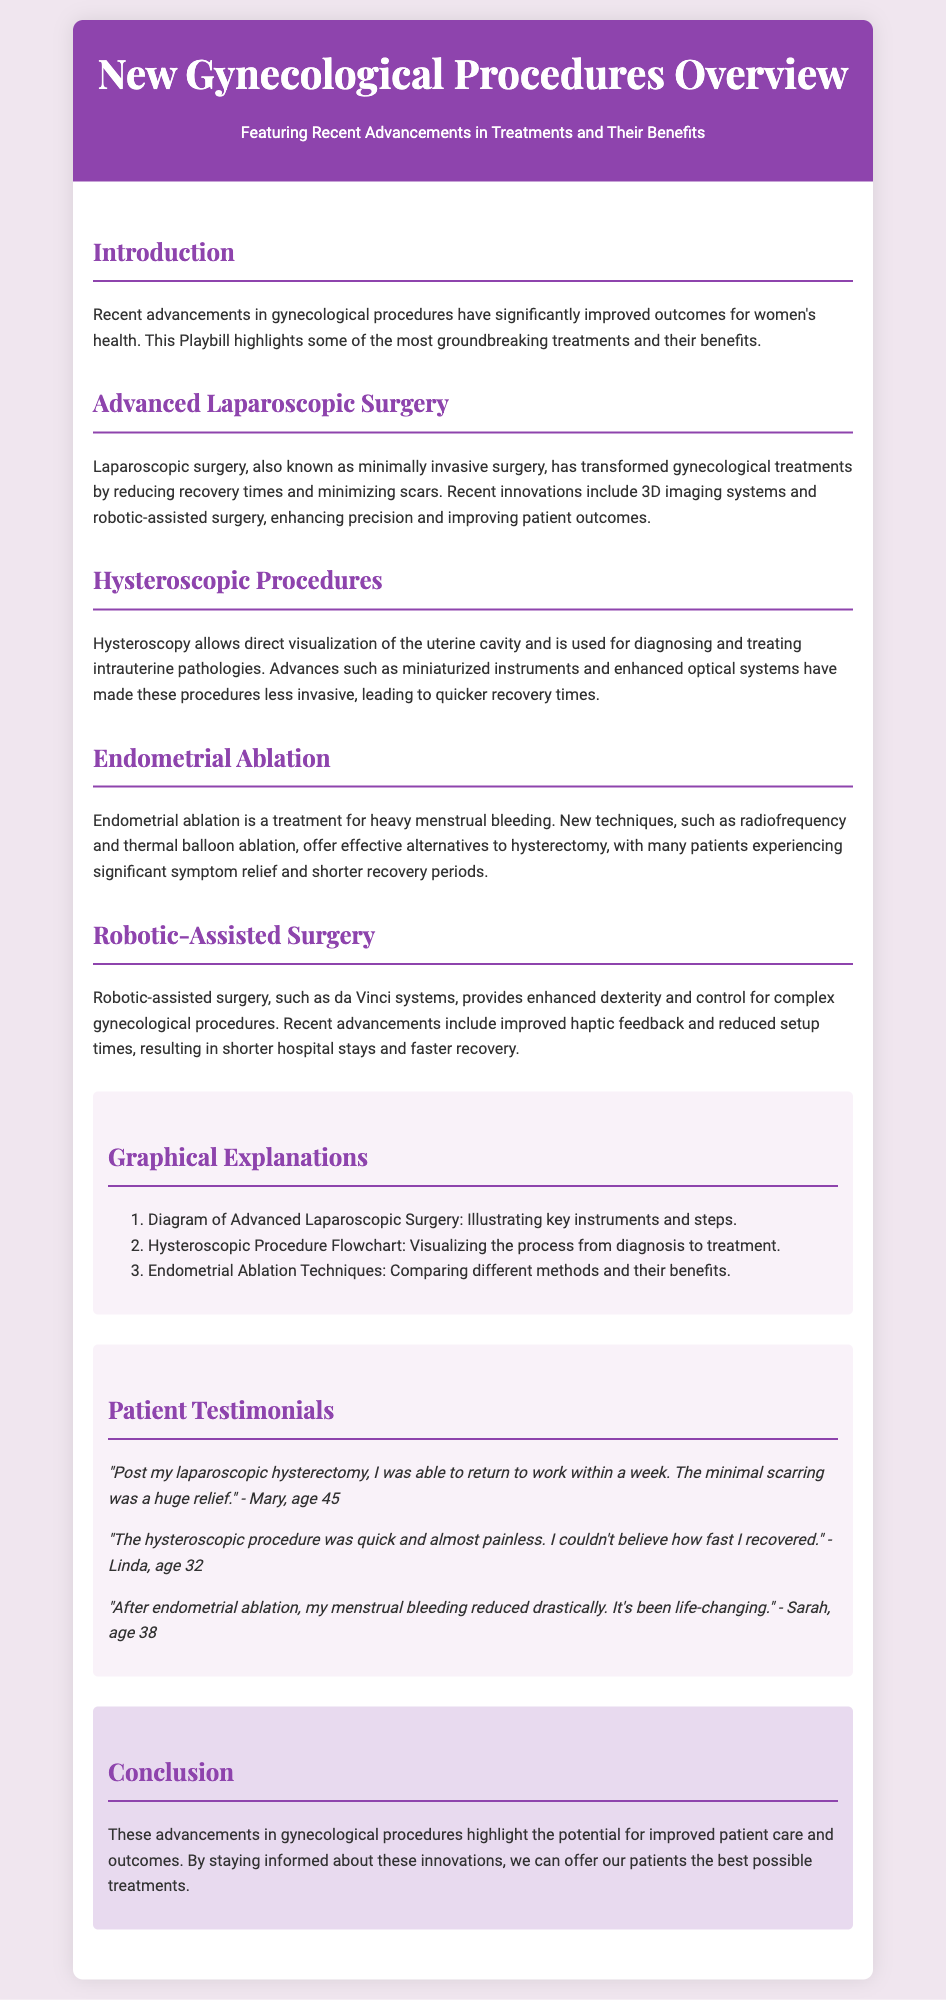What is the title of the Playbill? The title of the Playbill is mentioned at the beginning of the document, which is "New Gynecological Procedures Overview".
Answer: New Gynecological Procedures Overview What are the benefits of advanced laparoscopic surgery? The document states that it reduces recovery times and minimizes scars, indicating significant benefits.
Answer: Reduces recovery times and minimizes scars How many advanced procedures are highlighted in the document? The document lists four advanced procedures, which include laparoscopic surgery, hysteroscopic procedures, endometrial ablation, and robotic-assisted surgery.
Answer: Four Which technique offers effective alternatives to hysterectomy? The document specifies that endometrial ablation provides effective alternatives to hysterectomy for treating heavy menstrual bleeding.
Answer: Endometrial ablation What is the primary purpose of hysteroscopy? The document explains that hysteroscopy is used for diagnosing and treating intrauterine pathologies, indicating its primary purpose.
Answer: Diagnosing and treating intrauterine pathologies Who is the testimonial from that mentions returning to work within a week? The patient testimonial that mentions returning to work within a week after a laparoscopic hysterectomy is from Mary.
Answer: Mary What is one reason patients prefer robotic-assisted surgery? The document highlights that robotic-assisted surgery provides enhanced dexterity and control for complex procedures, which is a reason for patient preference.
Answer: Enhanced dexterity and control What type of information is presented in the "Graphical Explanations" section? The section contains diagrams and flowcharts illustrating key procedures and comparisons, emphasizing visual explanations of the treatments.
Answer: Diagrams and flowcharts What does the conclusion emphasize about patient care? The conclusion underscores the importance of staying informed about advancements to offer the best possible treatments for patients, focusing on improved care.
Answer: Improved patient care and outcomes 